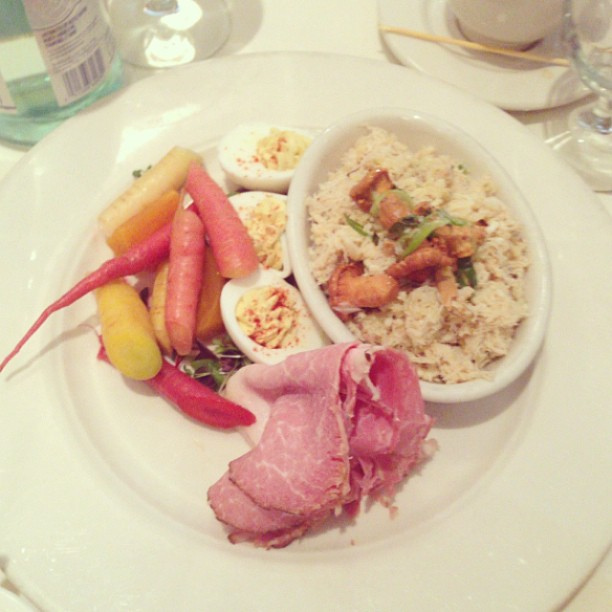<image>Why did you choose to eat at such a fancy restaurant? It is ambiguous why the person chose to eat at a fancy restaurant. The reasons can be varied like they are hungry, they want to have good quality food or maybe they are rich. Why did you choose to eat at such a fancy restaurant? I don't know why you choose to eat at such a fancy restaurant. It can be because you were hungry, liked the good food and its quality, or maybe you wanted to treat yourself to something nice. 